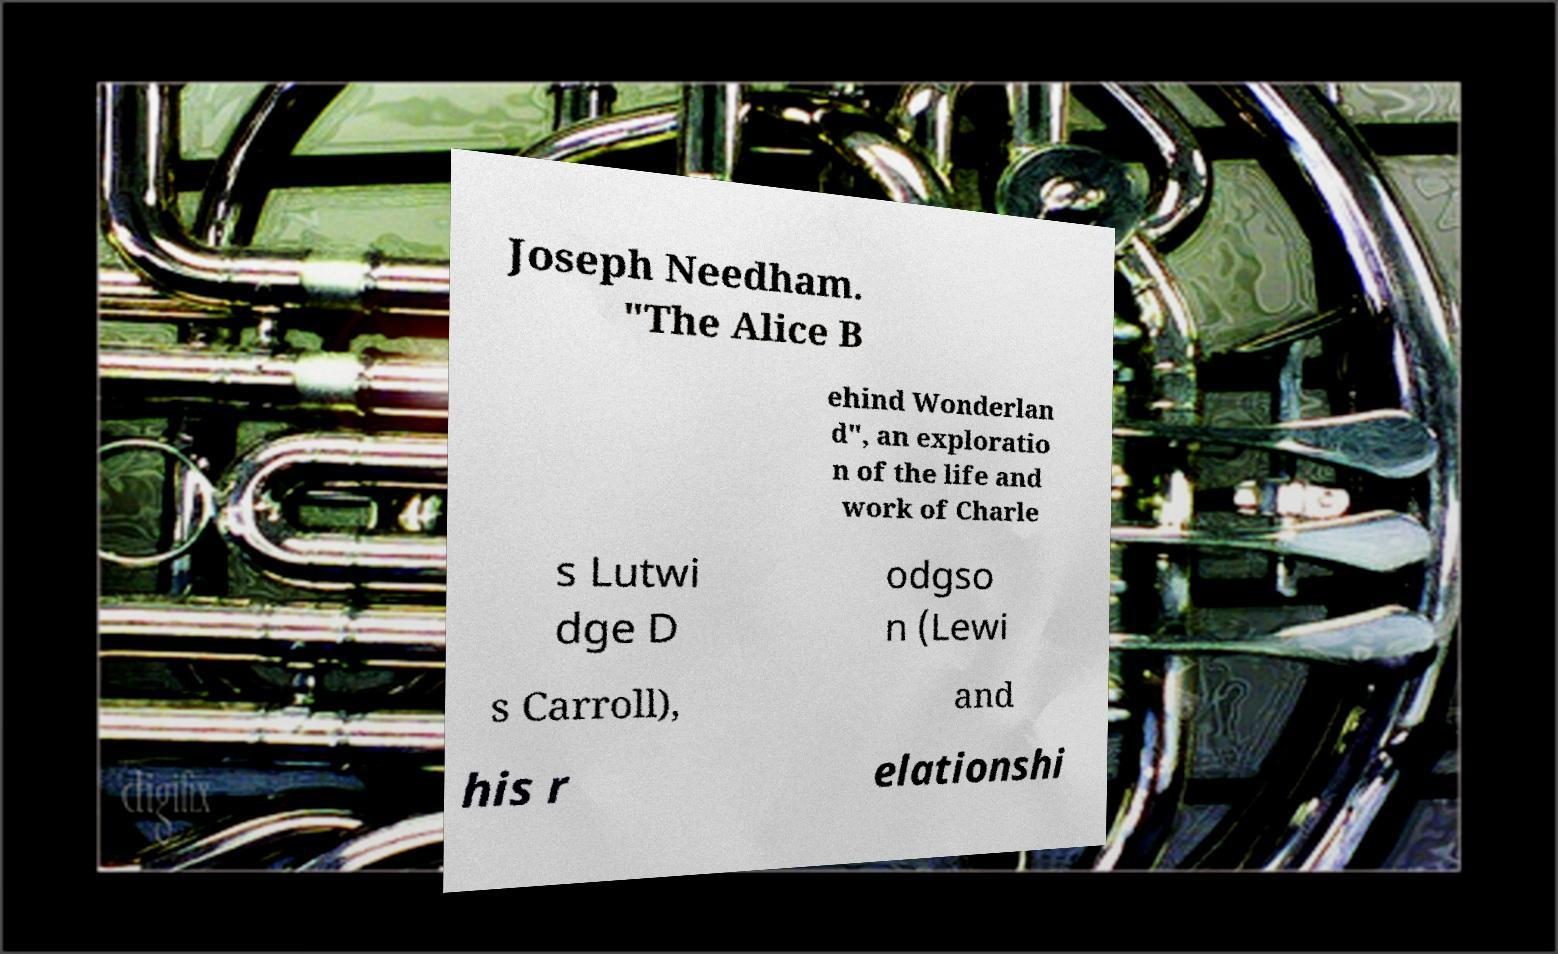For documentation purposes, I need the text within this image transcribed. Could you provide that? Joseph Needham. "The Alice B ehind Wonderlan d", an exploratio n of the life and work of Charle s Lutwi dge D odgso n (Lewi s Carroll), and his r elationshi 